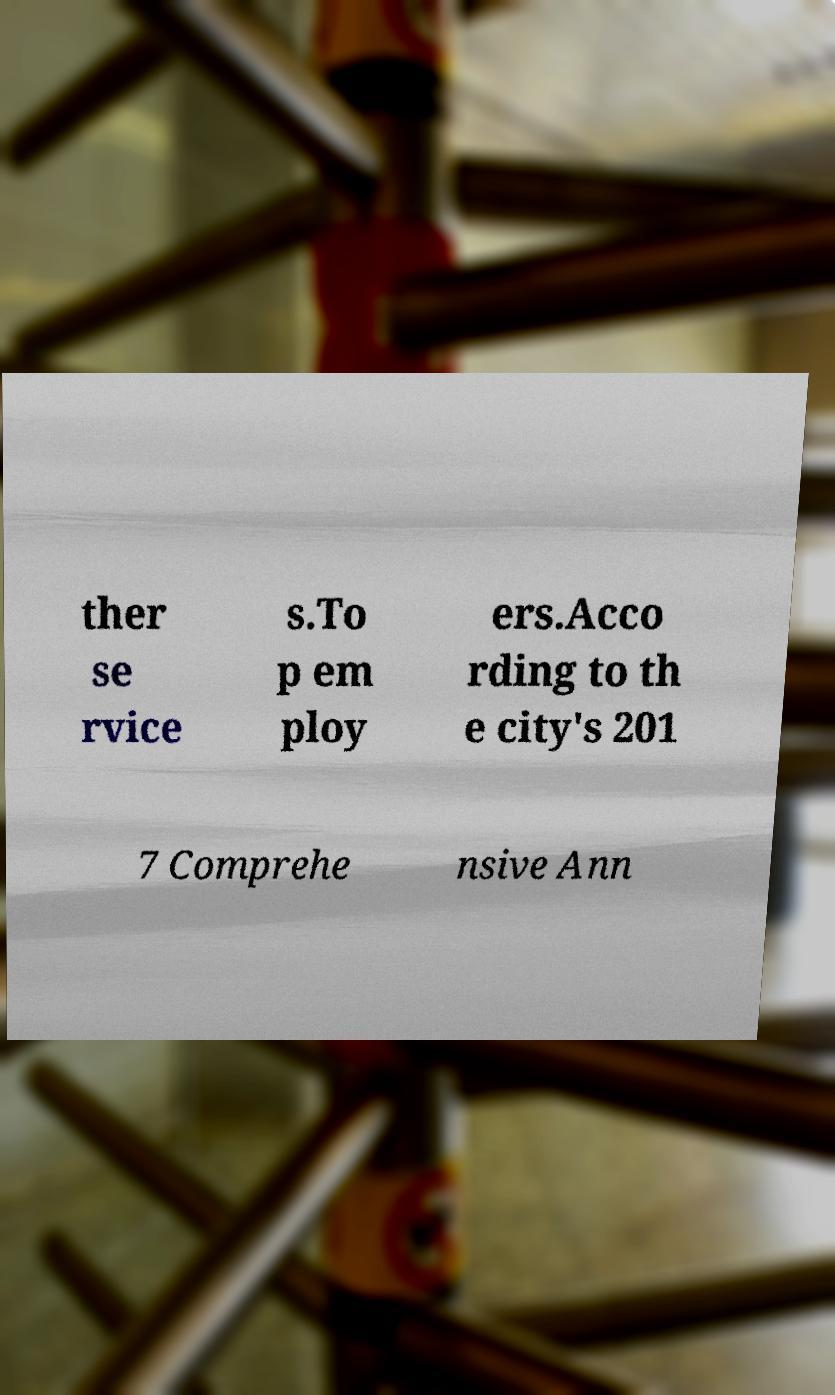Could you extract and type out the text from this image? ther se rvice s.To p em ploy ers.Acco rding to th e city's 201 7 Comprehe nsive Ann 